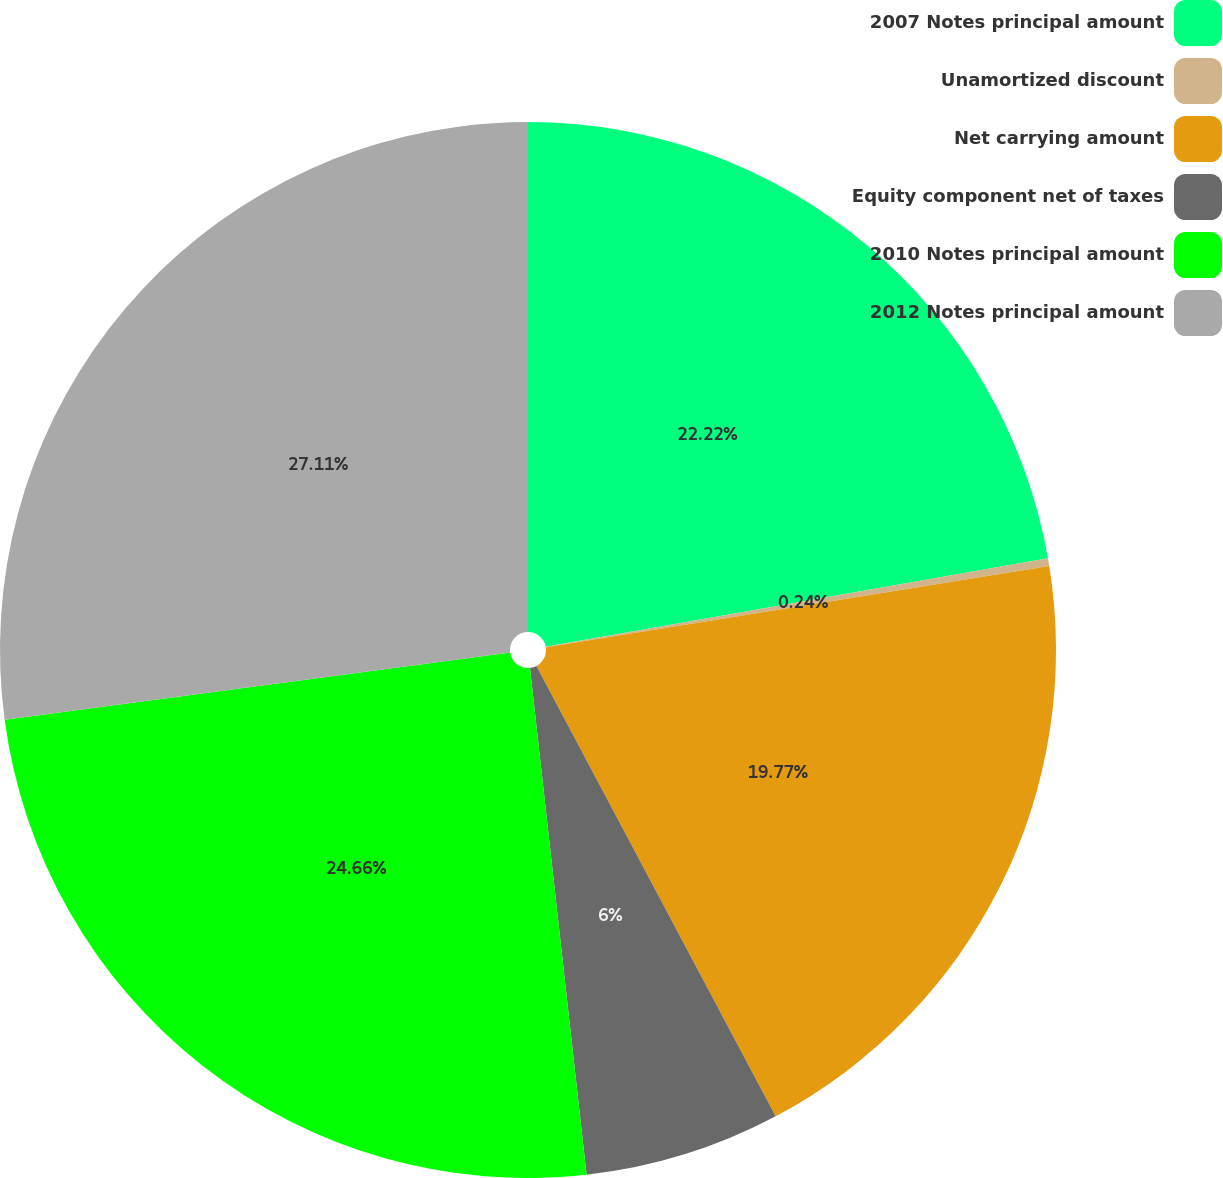Convert chart. <chart><loc_0><loc_0><loc_500><loc_500><pie_chart><fcel>2007 Notes principal amount<fcel>Unamortized discount<fcel>Net carrying amount<fcel>Equity component net of taxes<fcel>2010 Notes principal amount<fcel>2012 Notes principal amount<nl><fcel>22.22%<fcel>0.24%<fcel>19.77%<fcel>6.0%<fcel>24.66%<fcel>27.11%<nl></chart> 